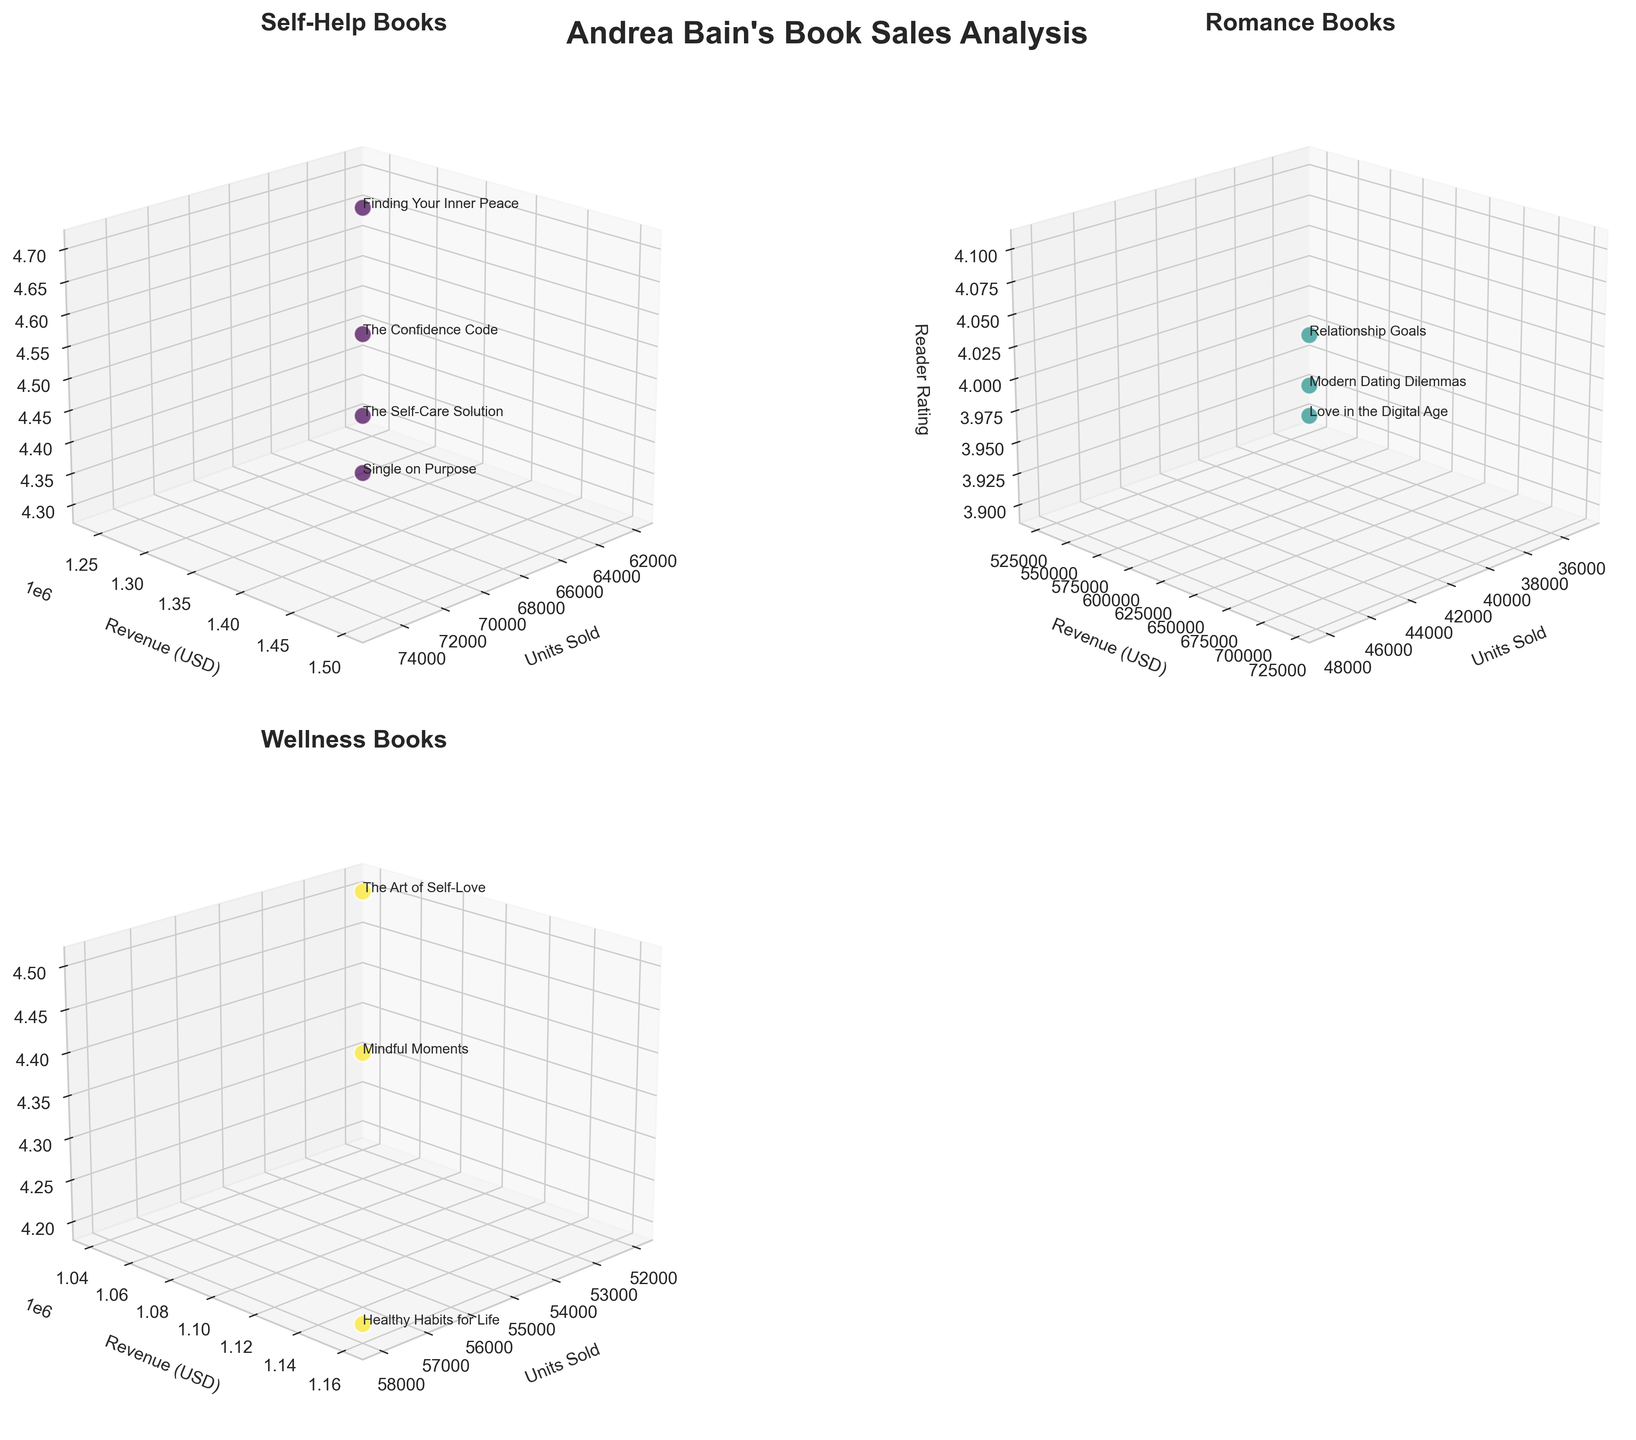How many self-help books are displayed in the plot? The subplot for the self-help genre shows data points labeled with the titles of the books. Count the number of unique data points (book titles) in the self-help subplot.
Answer: 4 Which genre shows the highest reader rating? Compare the highest reader rating values across the subplots for all genres. The subplot with the highest value on the Reader Rating (z-axis) will show the genre with the highest reader rating.
Answer: Self-Help What is the total revenue for romance books? To find the total revenue for romance books, sum the revenue values from the data points in the romance subplot. There are three romance books: $720,000 + $525,000 + $630,000 = $1,875,000.
Answer: $1,875,000 Which book has the highest units sold within the wellness genre? Look at the wellness subplot and identify the data point with the highest value on the Units Sold (x-axis). The book title associated with this highest value will be the answer.
Answer: Healthy Habits for Life Is there a significant difference in reader ratings between the genres? Compare the range and distribution of reader ratings (z-axis) across the different subplots. Assess whether any one genre has particularly higher or lower ratings compared to others.
Answer: Yes, self-help has consistently higher ratings What is the average revenue generated by self-help books? Calculate the average revenue by summing the revenue values for the self-help books and dividing by the number of self-help books. ($1,500,000 + $1,240,000 + $1,400,000 + $1,300,000) / 4 = $1,360,000.
Answer: $1,360,000 Which genre has the highest average reader rating? Calculate the average reader rating for each genre and compare them. The genre with the highest average is the answer. For example, self-help: (4.5 + 4.3 + 4.6 + 4.7)/4 = 4.525, wellness: (4.4 + 4.2 + 4.5)/3 = 4.367.
Answer: Self-Help What is the relationship between units sold and revenue generated in the romance genre? Observe the romance subplot and assess the pattern between Units Sold (x-axis) and Revenue (y-axis). Usually, higher units sold correspond to higher revenue.
Answer: Positive correlation Do all books in the self-help genre have reader ratings higher than 4.0? Check the reader ratings (z-axis) of all the data points in the self-help subplot and confirm if each rating is above 4.0.
Answer: Yes Which wellness book has the highest revenue? In the wellness subplot, identify the data point with the highest value on the Revenue (y-axis), then find the associated book title.
Answer: Healthy Habits for Life 